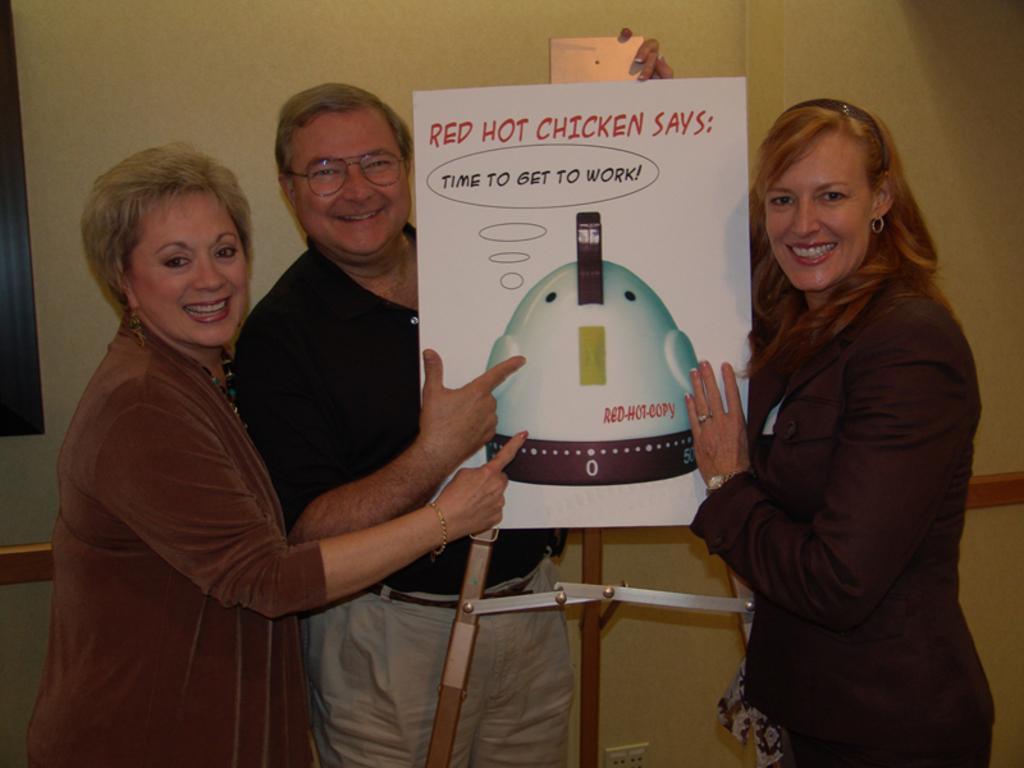Could you give a brief overview of what you see in this image? In this picture there are people standing and we can see board on stand. In the background of the image we can see wall. 